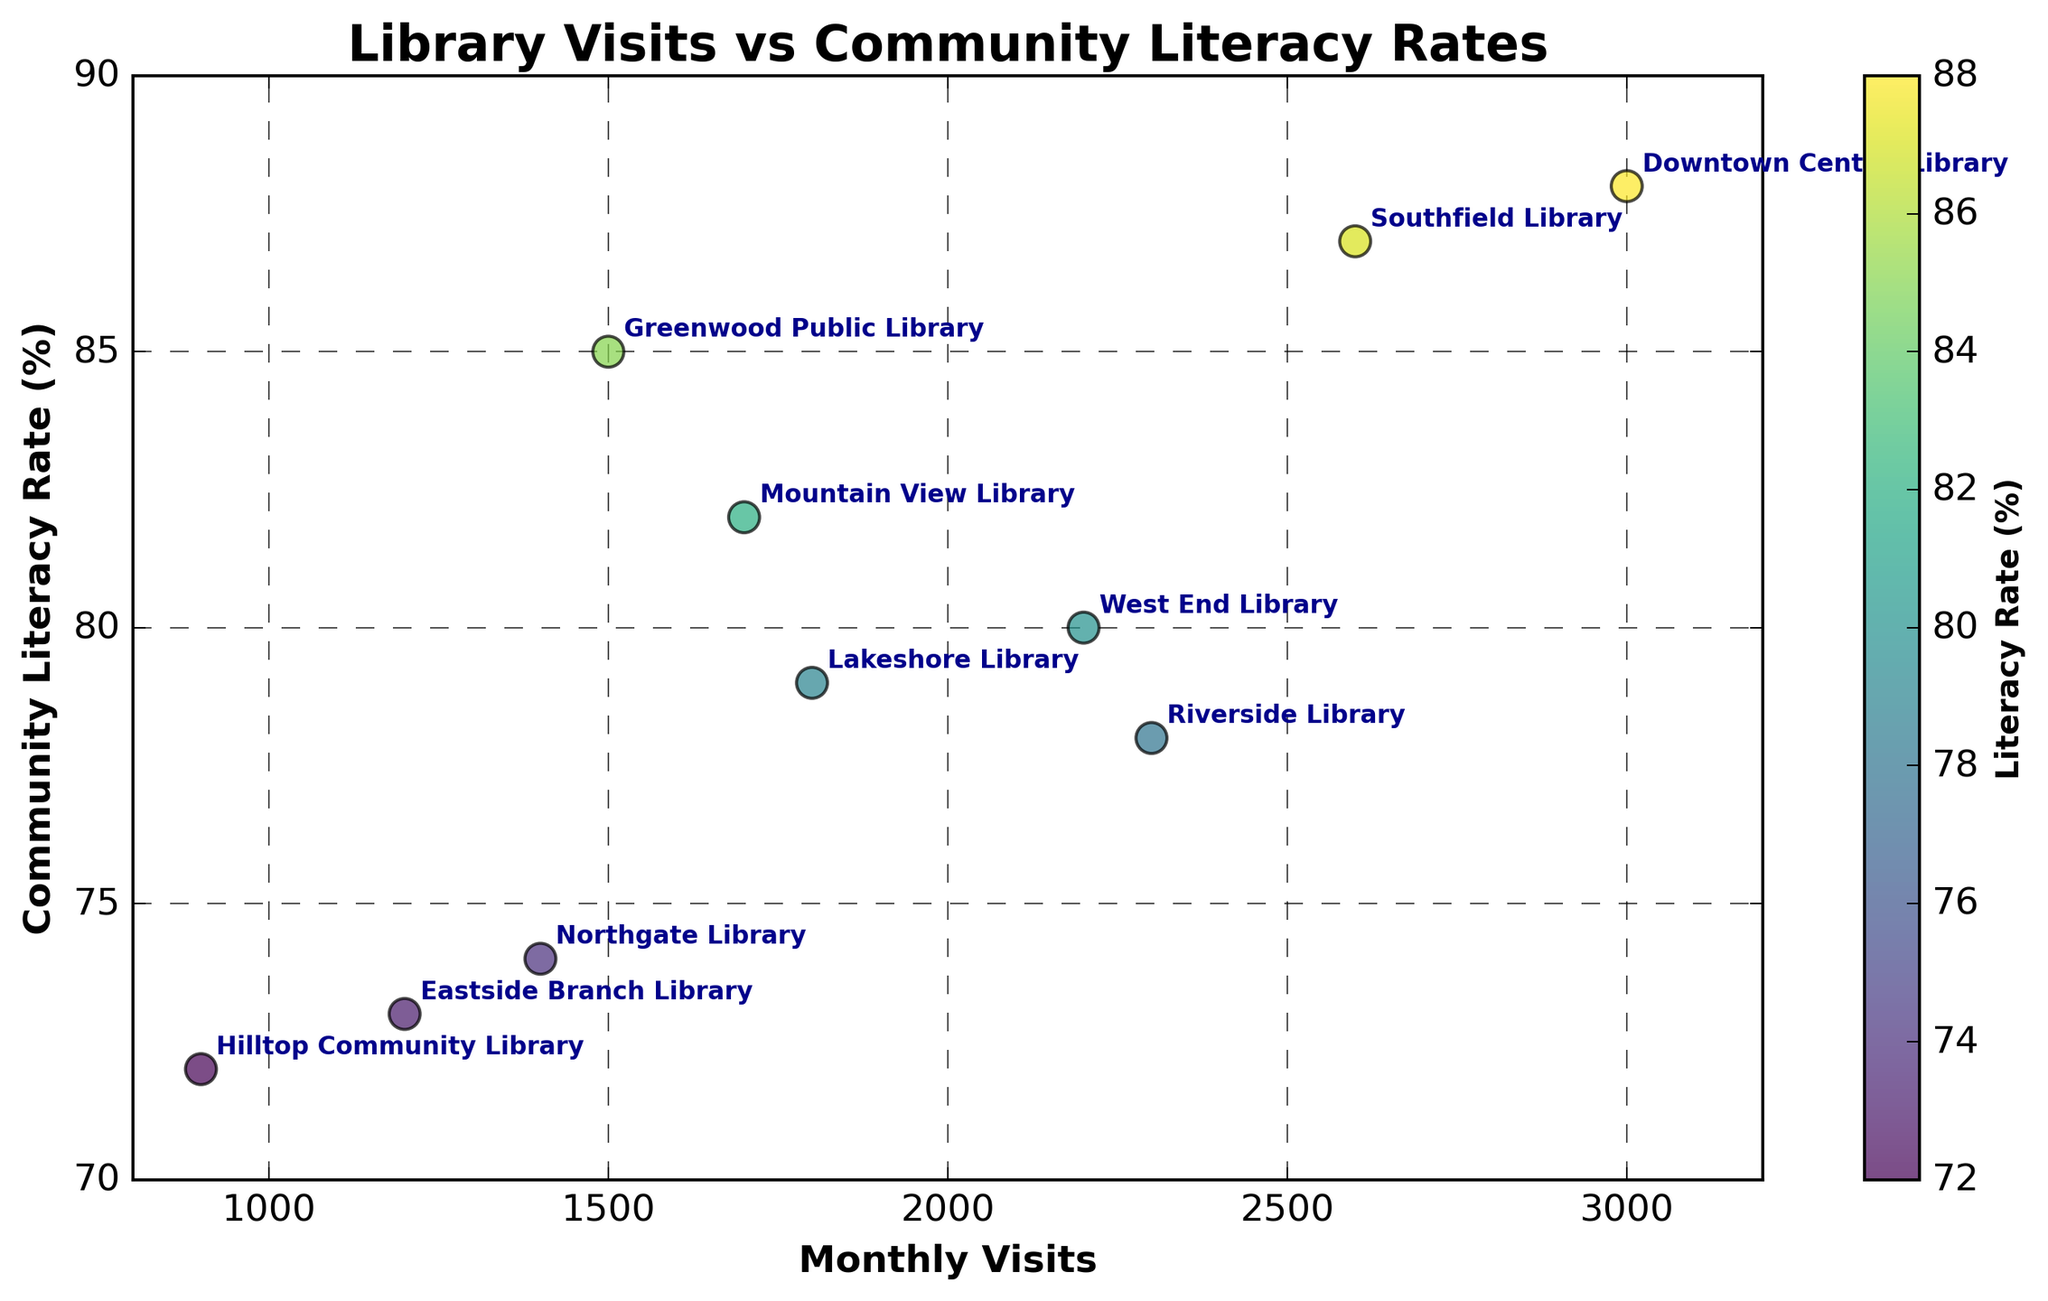Which library has the highest monthly visits? The highest point on the x-axis represents the library with the greatest number of monthly visits. Annotating the figure reveals "Downtown Central Library" at 3000 visits.
Answer: Downtown Central Library What is the community literacy rate for Eastside Branch Library? Identify the point associated with Eastside Branch Library and note its corresponding y-axis value. The annotation shows Eastside Branch Library at a literacy rate of 73%.
Answer: 73% Which library has the lowest community literacy rate, and what is the rate? The lowest point on the y-axis corresponds to the library with the lowest community literacy rate. The annotation indicates "Hilltop Community Library" at a rate of 72%.
Answer: Hilltop Community Library, 72% What is the average community literacy rate for libraries with more than 2000 monthly visits? Identify libraries with over 2000 visits: Downtown Central Library (88%), Riverside Library (78%), Southfield Library (87%), and West End Library (80%). Calculate: (88 + 78 + 87 + 80) / 4 = 83.25%.
Answer: 83.25% How does the literacy rate of Northgate Library compare to that of Southfield Library? Compare Northgate Library's literacy rate (74%) to Southfield Library's (87%). Southfield Library has a higher literacy rate by 13 percentage points.
Answer: Southfield Library has a higher rate by 13% Is there any visible trend between monthly visits and literacy rates? Observing the scatter plot, there's a general upward trend, where higher monthly visits seem to correlate with higher literacy rates. This suggests a positive relationship between visits and literacy rates.
Answer: Positive relationship Which two libraries have exactly the same community literacy rate? By examining the points on the plot, Greenwood Public Library (85%) and Downtown Central Library (88%) each have unique literacy rates. Closest matches are not exact duplicates, but computation can isolate almost similar rates.
Answer: No exact matches, closest are Greenwood Public Library and Southfield Library with 85% and 87% respectively What is the range of monthly visits between the least and most visited libraries? Identify the least visited (Hilltop Community Library at 900 visits) and the most visited (Downtown Central Library at 3000 visits). Compute the range: 3000 - 900 = 2100.
Answer: 2100 How many libraries have a community literacy rate below 80%? Count the points with y-axis values less than 80%. Libraries: Riverside Library, Eastside Branch Library, Lakeshore Library, Hilltop Community Library, Northgate Library. Total = 5 libraries.
Answer: 5 Do any libraries with fewer than 1500 monthly visits have literacy rates above 80%? Check libraries below 1500 visits: Northgate Library (74%), Eastside Branch Library (73%), and Hilltop Community Library (72%) all have literacy rates below 80%.
Answer: No 